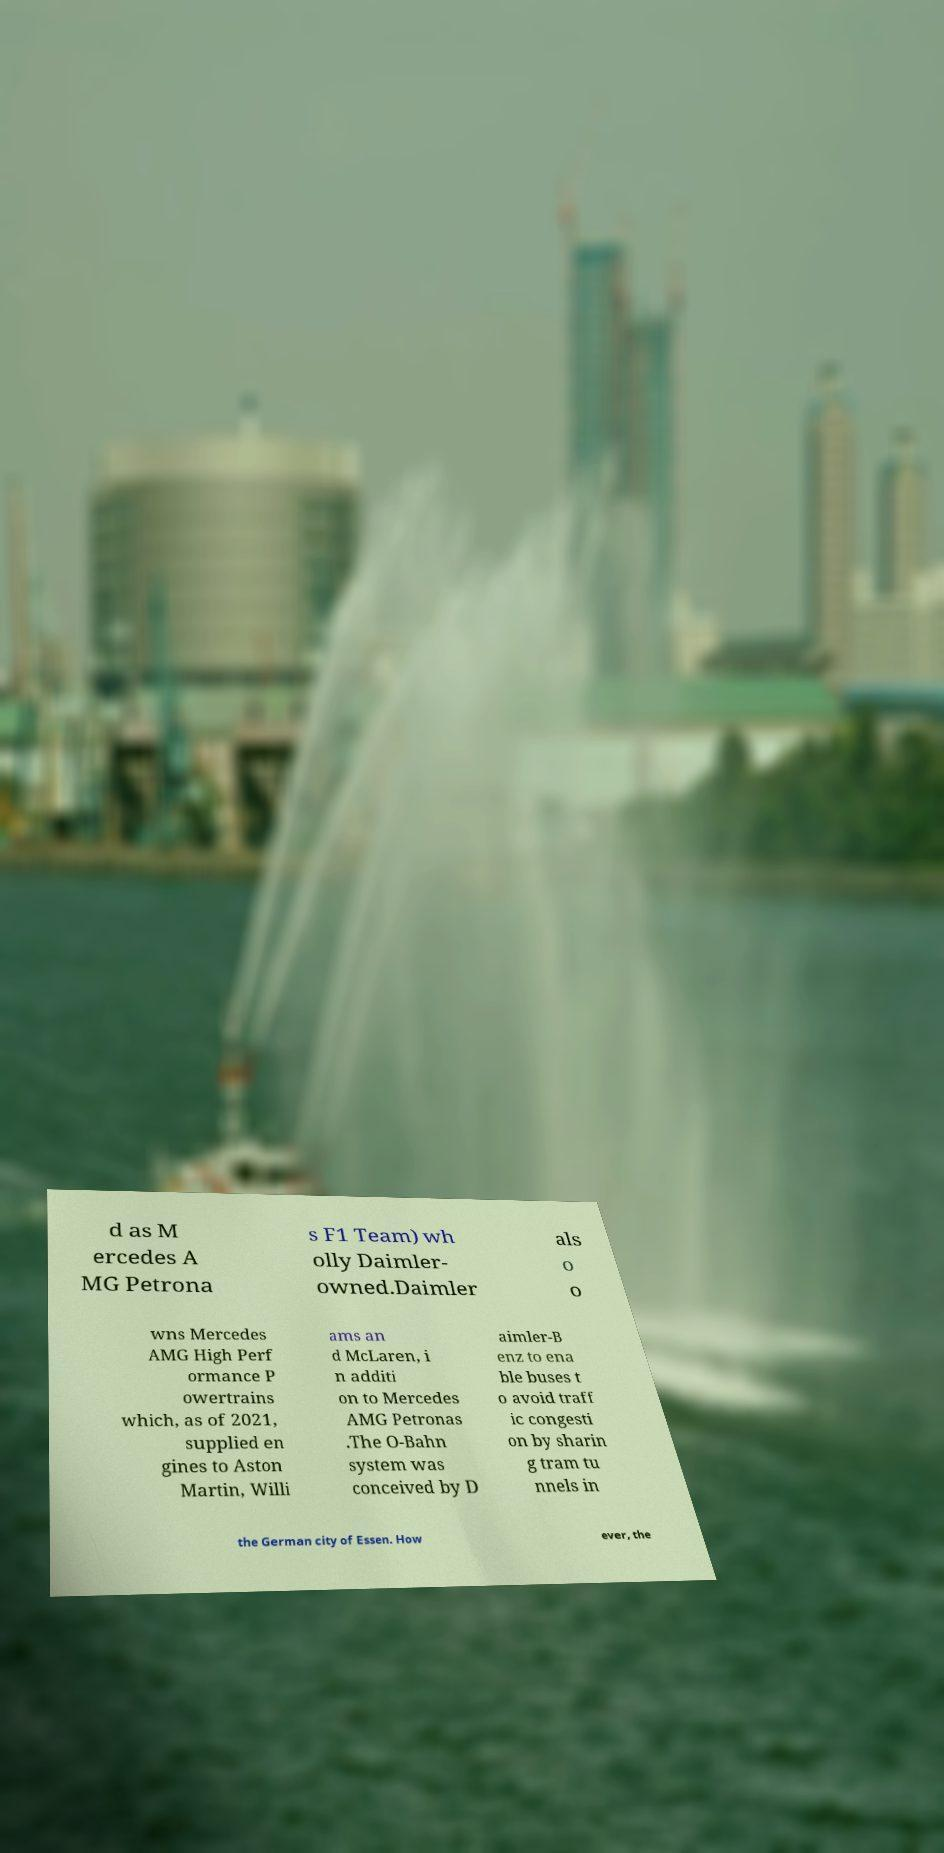What messages or text are displayed in this image? I need them in a readable, typed format. d as M ercedes A MG Petrona s F1 Team) wh olly Daimler- owned.Daimler als o o wns Mercedes AMG High Perf ormance P owertrains which, as of 2021, supplied en gines to Aston Martin, Willi ams an d McLaren, i n additi on to Mercedes AMG Petronas .The O-Bahn system was conceived by D aimler-B enz to ena ble buses t o avoid traff ic congesti on by sharin g tram tu nnels in the German city of Essen. How ever, the 